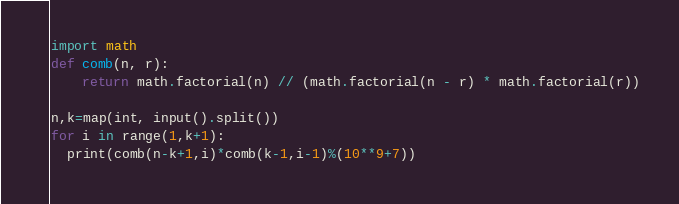Convert code to text. <code><loc_0><loc_0><loc_500><loc_500><_Python_>import math
def comb(n, r):
    return math.factorial(n) // (math.factorial(n - r) * math.factorial(r))

n,k=map(int, input().split())
for i in range(1,k+1):
  print(comb(n-k+1,i)*comb(k-1,i-1)%(10**9+7))</code> 